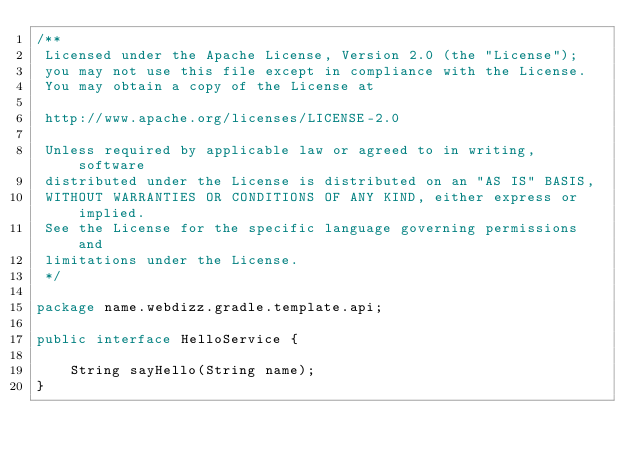<code> <loc_0><loc_0><loc_500><loc_500><_Java_>/**
 Licensed under the Apache License, Version 2.0 (the "License");
 you may not use this file except in compliance with the License.
 You may obtain a copy of the License at

 http://www.apache.org/licenses/LICENSE-2.0

 Unless required by applicable law or agreed to in writing, software
 distributed under the License is distributed on an "AS IS" BASIS,
 WITHOUT WARRANTIES OR CONDITIONS OF ANY KIND, either express or implied.
 See the License for the specific language governing permissions and
 limitations under the License.
 */

package name.webdizz.gradle.template.api;

public interface HelloService {

    String sayHello(String name);
}
</code> 